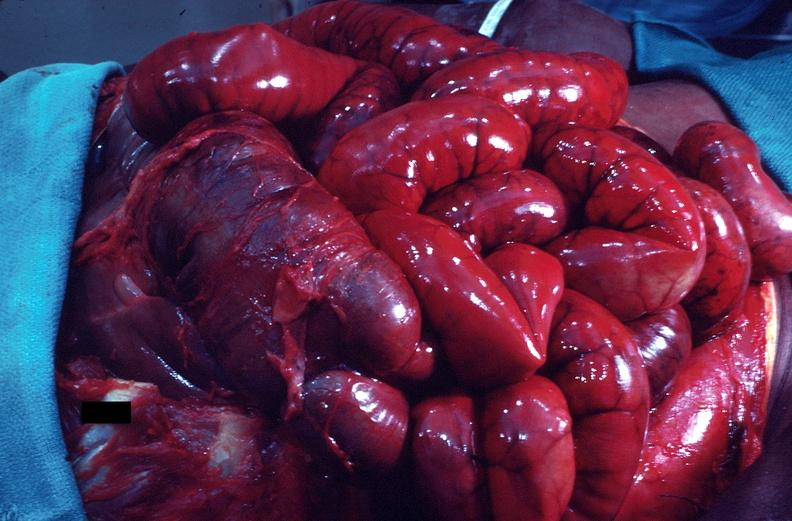s leiomyosarcoma present?
Answer the question using a single word or phrase. No 